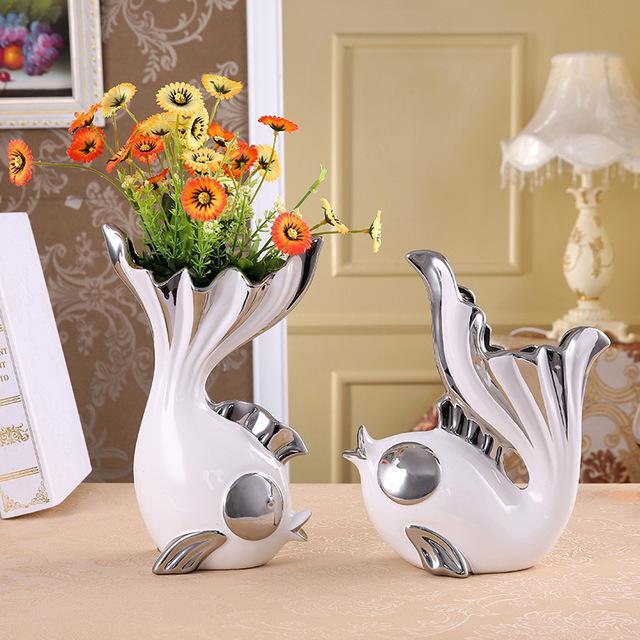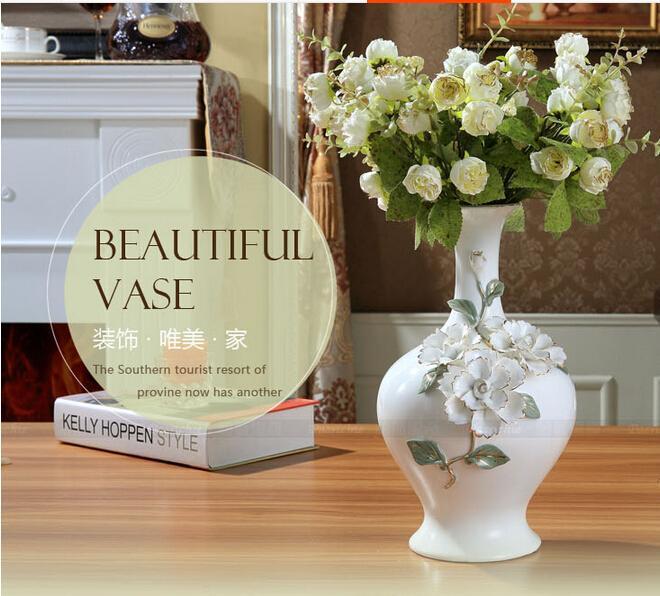The first image is the image on the left, the second image is the image on the right. Considering the images on both sides, is "there are lit candles in glass vases" valid? Answer yes or no. No. 